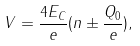Convert formula to latex. <formula><loc_0><loc_0><loc_500><loc_500>V = \frac { 4 E _ { C } } { e } ( n \pm \frac { Q _ { 0 } } { e } ) ,</formula> 